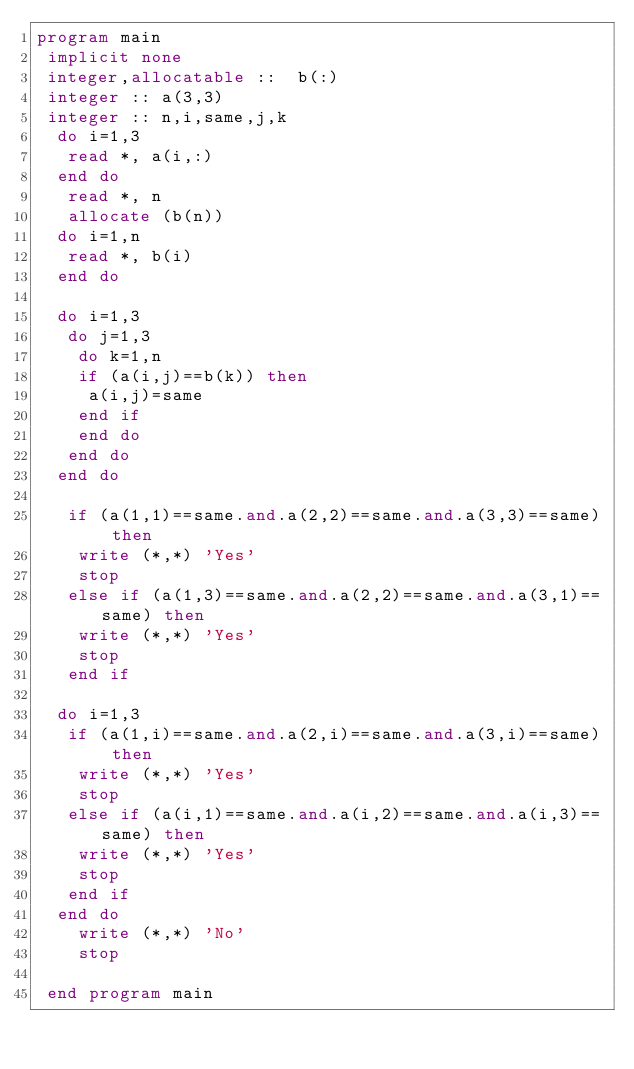Convert code to text. <code><loc_0><loc_0><loc_500><loc_500><_FORTRAN_>program main 
 implicit none 
 integer,allocatable ::  b(:)
 integer :: a(3,3)
 integer :: n,i,same,j,k
  do i=1,3
   read *, a(i,:)
  end do
   read *, n
   allocate (b(n))
  do i=1,n
   read *, b(i)
  end do
  
  do i=1,3
   do j=1,3
    do k=1,n
    if (a(i,j)==b(k)) then
     a(i,j)=same
    end if
    end do
   end do
  end do
  
   if (a(1,1)==same.and.a(2,2)==same.and.a(3,3)==same) then
    write (*,*) 'Yes' 
    stop
   else if (a(1,3)==same.and.a(2,2)==same.and.a(3,1)==same) then
    write (*,*) 'Yes'
    stop
   end if
   
  do i=1,3
   if (a(1,i)==same.and.a(2,i)==same.and.a(3,i)==same) then
    write (*,*) 'Yes'
    stop
   else if (a(i,1)==same.and.a(i,2)==same.and.a(i,3)==same) then
    write (*,*) 'Yes'
    stop
   end if
  end do
    write (*,*) 'No'
    stop
    
 end program main
</code> 